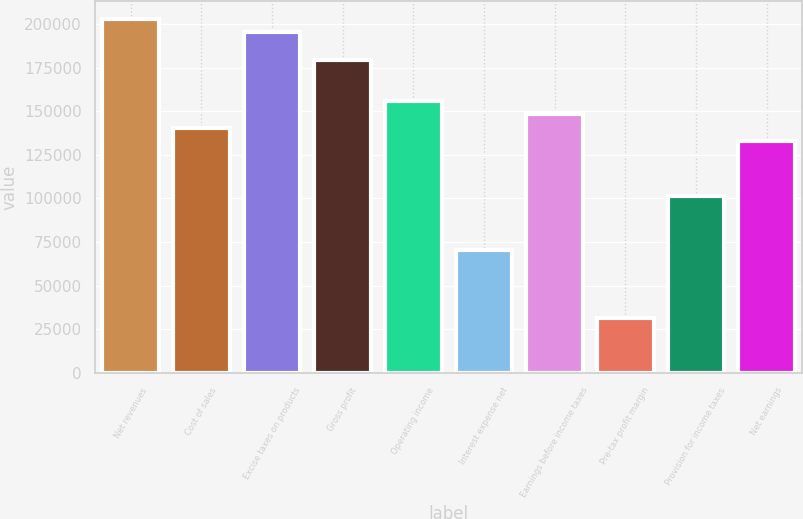Convert chart to OTSL. <chart><loc_0><loc_0><loc_500><loc_500><bar_chart><fcel>Net revenues<fcel>Cost of sales<fcel>Excise taxes on products<fcel>Gross profit<fcel>Operating income<fcel>Interest expense net<fcel>Earnings before income taxes<fcel>Pre-tax profit margin<fcel>Provision for income taxes<fcel>Net earnings<nl><fcel>203056<fcel>140578<fcel>195246<fcel>179626<fcel>156197<fcel>70290.3<fcel>148388<fcel>31241.7<fcel>101529<fcel>132768<nl></chart> 